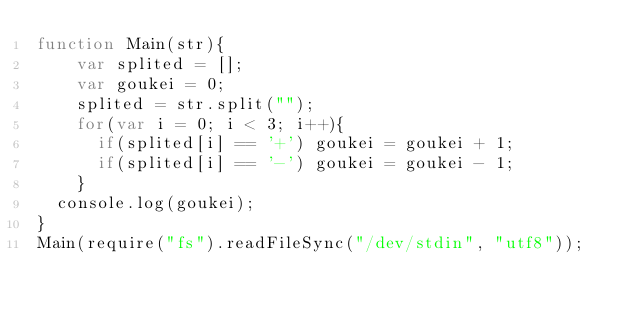<code> <loc_0><loc_0><loc_500><loc_500><_JavaScript_>function Main(str){
    var splited = [];
    var goukei = 0;
    splited = str.split("");
    for(var i = 0; i < 3; i++){
      if(splited[i] == '+') goukei = goukei + 1;
      if(splited[i] == '-') goukei = goukei - 1;
    }
  console.log(goukei);
}
Main(require("fs").readFileSync("/dev/stdin", "utf8"));</code> 